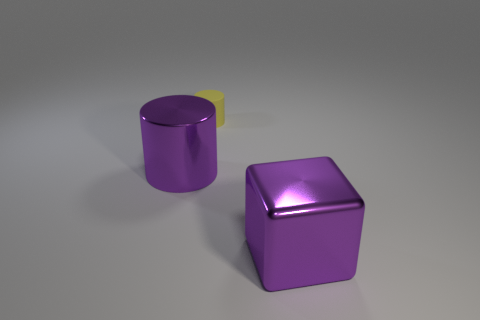Is the rubber thing the same size as the purple shiny cylinder?
Provide a succinct answer. No. What number of blocks are either small objects or big purple objects?
Offer a terse response. 1. There is a purple metal object that is to the left of the small yellow rubber object; how many large cylinders are left of it?
Make the answer very short. 0. The metal object that is the same shape as the small matte thing is what size?
Provide a succinct answer. Large. There is a purple metal object on the left side of the metallic object that is in front of the metal cylinder; what shape is it?
Your answer should be compact. Cylinder. The metallic cube has what size?
Ensure brevity in your answer.  Large. The rubber object is what shape?
Keep it short and to the point. Cylinder. There is a tiny yellow thing; is it the same shape as the large purple metallic object on the left side of the small yellow cylinder?
Keep it short and to the point. Yes. There is a purple metallic thing that is left of the tiny yellow matte cylinder; is its shape the same as the tiny thing?
Your answer should be very brief. Yes. How many purple shiny objects are both to the left of the yellow rubber thing and to the right of the yellow thing?
Provide a short and direct response. 0. 